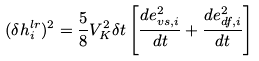<formula> <loc_0><loc_0><loc_500><loc_500>( \delta h _ { i } ^ { l r } ) ^ { 2 } = \frac { 5 } { 8 } V _ { K } ^ { 2 } \delta t \left [ \frac { d e _ { v s , i } ^ { 2 } } { d t } + \frac { d e _ { d f , i } ^ { 2 } } { d t } \right ]</formula> 